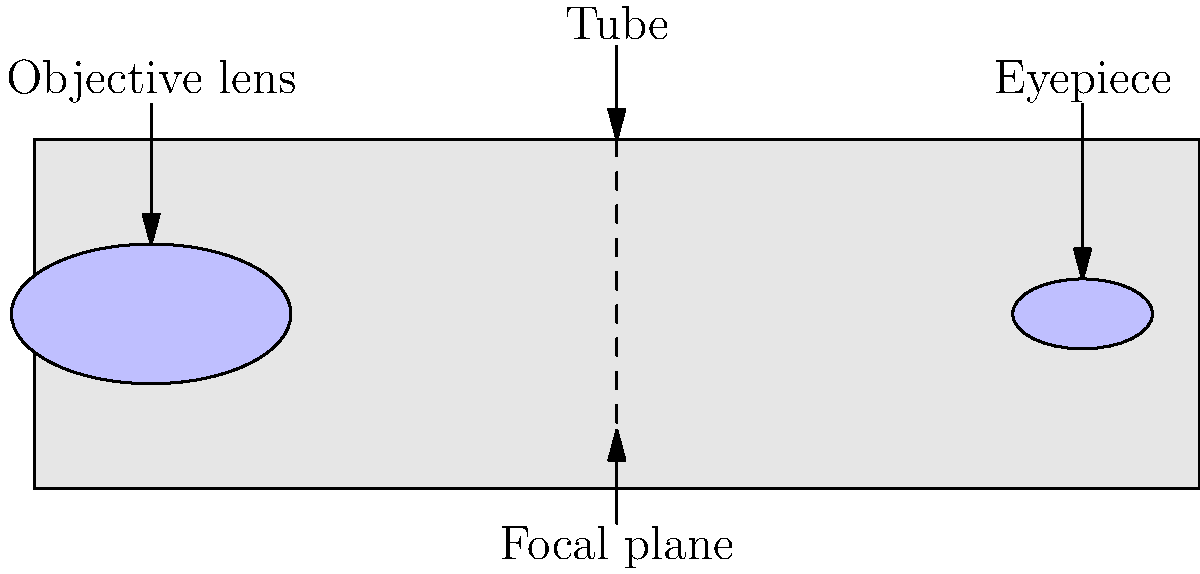In a refracting telescope, which component is responsible for gathering and focusing light from distant objects, similar to how a tennis player's eyes focus on an incoming serve? To understand the function of a refracting telescope, let's break it down step-by-step:

1. A refracting telescope consists of several key components, including the objective lens, eyepiece, focal plane, and tube.

2. The objective lens is the large lens at the front of the telescope (left side in the diagram). Its primary function is to gather light from distant objects and focus it.

3. This is similar to how a tennis player's eyes focus on an incoming serve, collecting light reflected from the ball to form an image.

4. The objective lens bends (refracts) the incoming light rays, causing them to converge at the focal plane.

5. The eyepiece, located at the opposite end of the telescope (right side in the diagram), then magnifies this focused image for viewing.

6. The tube holds all these components in proper alignment, much like how a tennis racket's frame holds the strings in place for optimal performance.

7. In the context of the question, we're looking for the component that initially gathers and focuses the light, which is the primary function of the objective lens.
Answer: Objective lens 